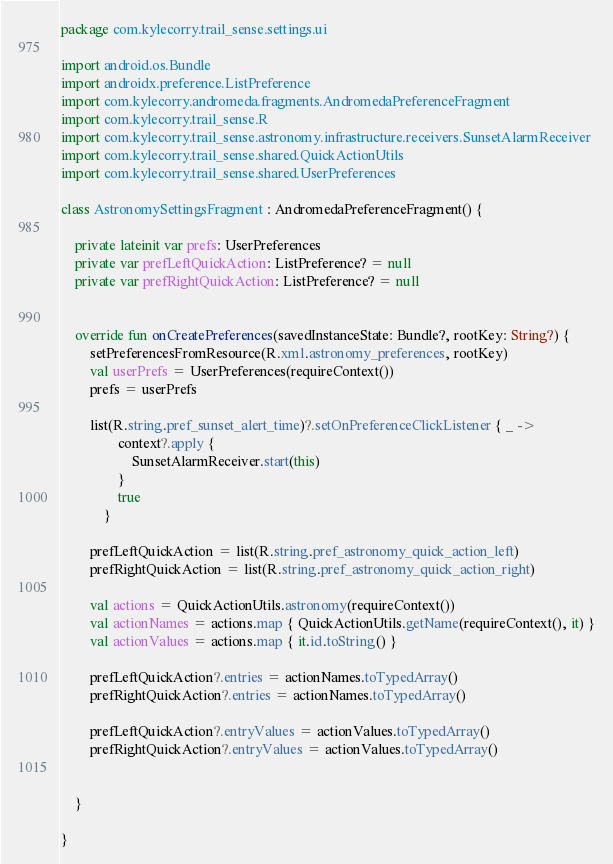<code> <loc_0><loc_0><loc_500><loc_500><_Kotlin_>package com.kylecorry.trail_sense.settings.ui

import android.os.Bundle
import androidx.preference.ListPreference
import com.kylecorry.andromeda.fragments.AndromedaPreferenceFragment
import com.kylecorry.trail_sense.R
import com.kylecorry.trail_sense.astronomy.infrastructure.receivers.SunsetAlarmReceiver
import com.kylecorry.trail_sense.shared.QuickActionUtils
import com.kylecorry.trail_sense.shared.UserPreferences

class AstronomySettingsFragment : AndromedaPreferenceFragment() {

    private lateinit var prefs: UserPreferences
    private var prefLeftQuickAction: ListPreference? = null
    private var prefRightQuickAction: ListPreference? = null


    override fun onCreatePreferences(savedInstanceState: Bundle?, rootKey: String?) {
        setPreferencesFromResource(R.xml.astronomy_preferences, rootKey)
        val userPrefs = UserPreferences(requireContext())
        prefs = userPrefs

        list(R.string.pref_sunset_alert_time)?.setOnPreferenceClickListener { _ ->
                context?.apply {
                    SunsetAlarmReceiver.start(this)
                }
                true
            }

        prefLeftQuickAction = list(R.string.pref_astronomy_quick_action_left)
        prefRightQuickAction = list(R.string.pref_astronomy_quick_action_right)

        val actions = QuickActionUtils.astronomy(requireContext())
        val actionNames = actions.map { QuickActionUtils.getName(requireContext(), it) }
        val actionValues = actions.map { it.id.toString() }

        prefLeftQuickAction?.entries = actionNames.toTypedArray()
        prefRightQuickAction?.entries = actionNames.toTypedArray()

        prefLeftQuickAction?.entryValues = actionValues.toTypedArray()
        prefRightQuickAction?.entryValues = actionValues.toTypedArray()


    }

}</code> 